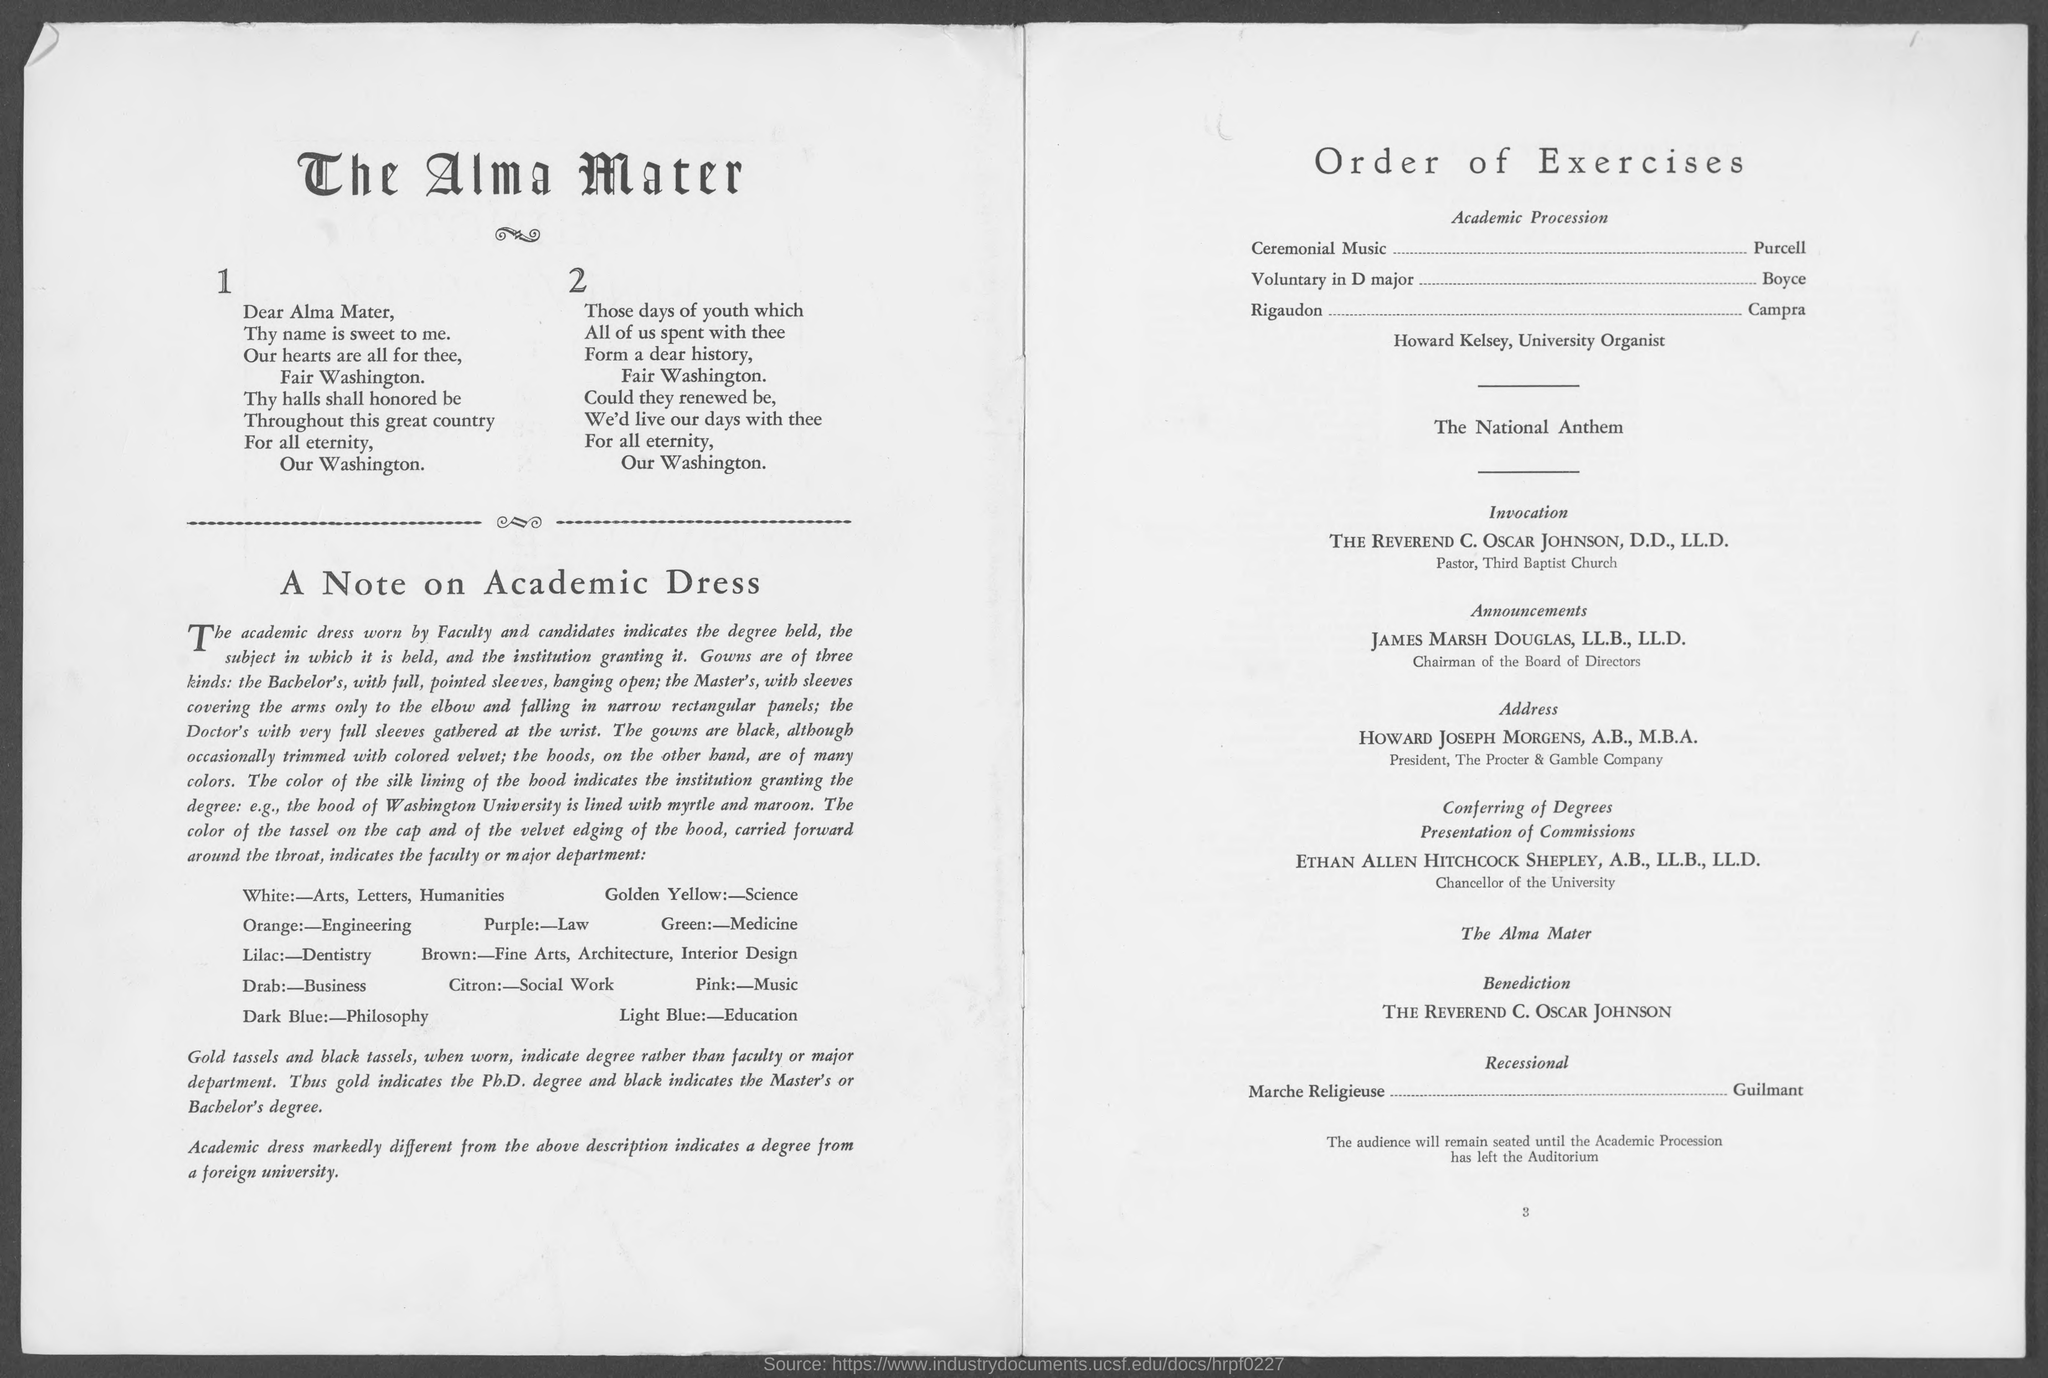Point out several critical features in this image. Howard Joseph Morgens holds the designation of President of The Procter & Gamble Company, having obtained both an A.B. and an M.B.A. James Marsh Douglas, LL.B., LL.D., is the Chairman of the Board of Directors. The Reverend C. Oscar Johnson, D.D., LL.D., is the Pastor of Third Baptist Church. 